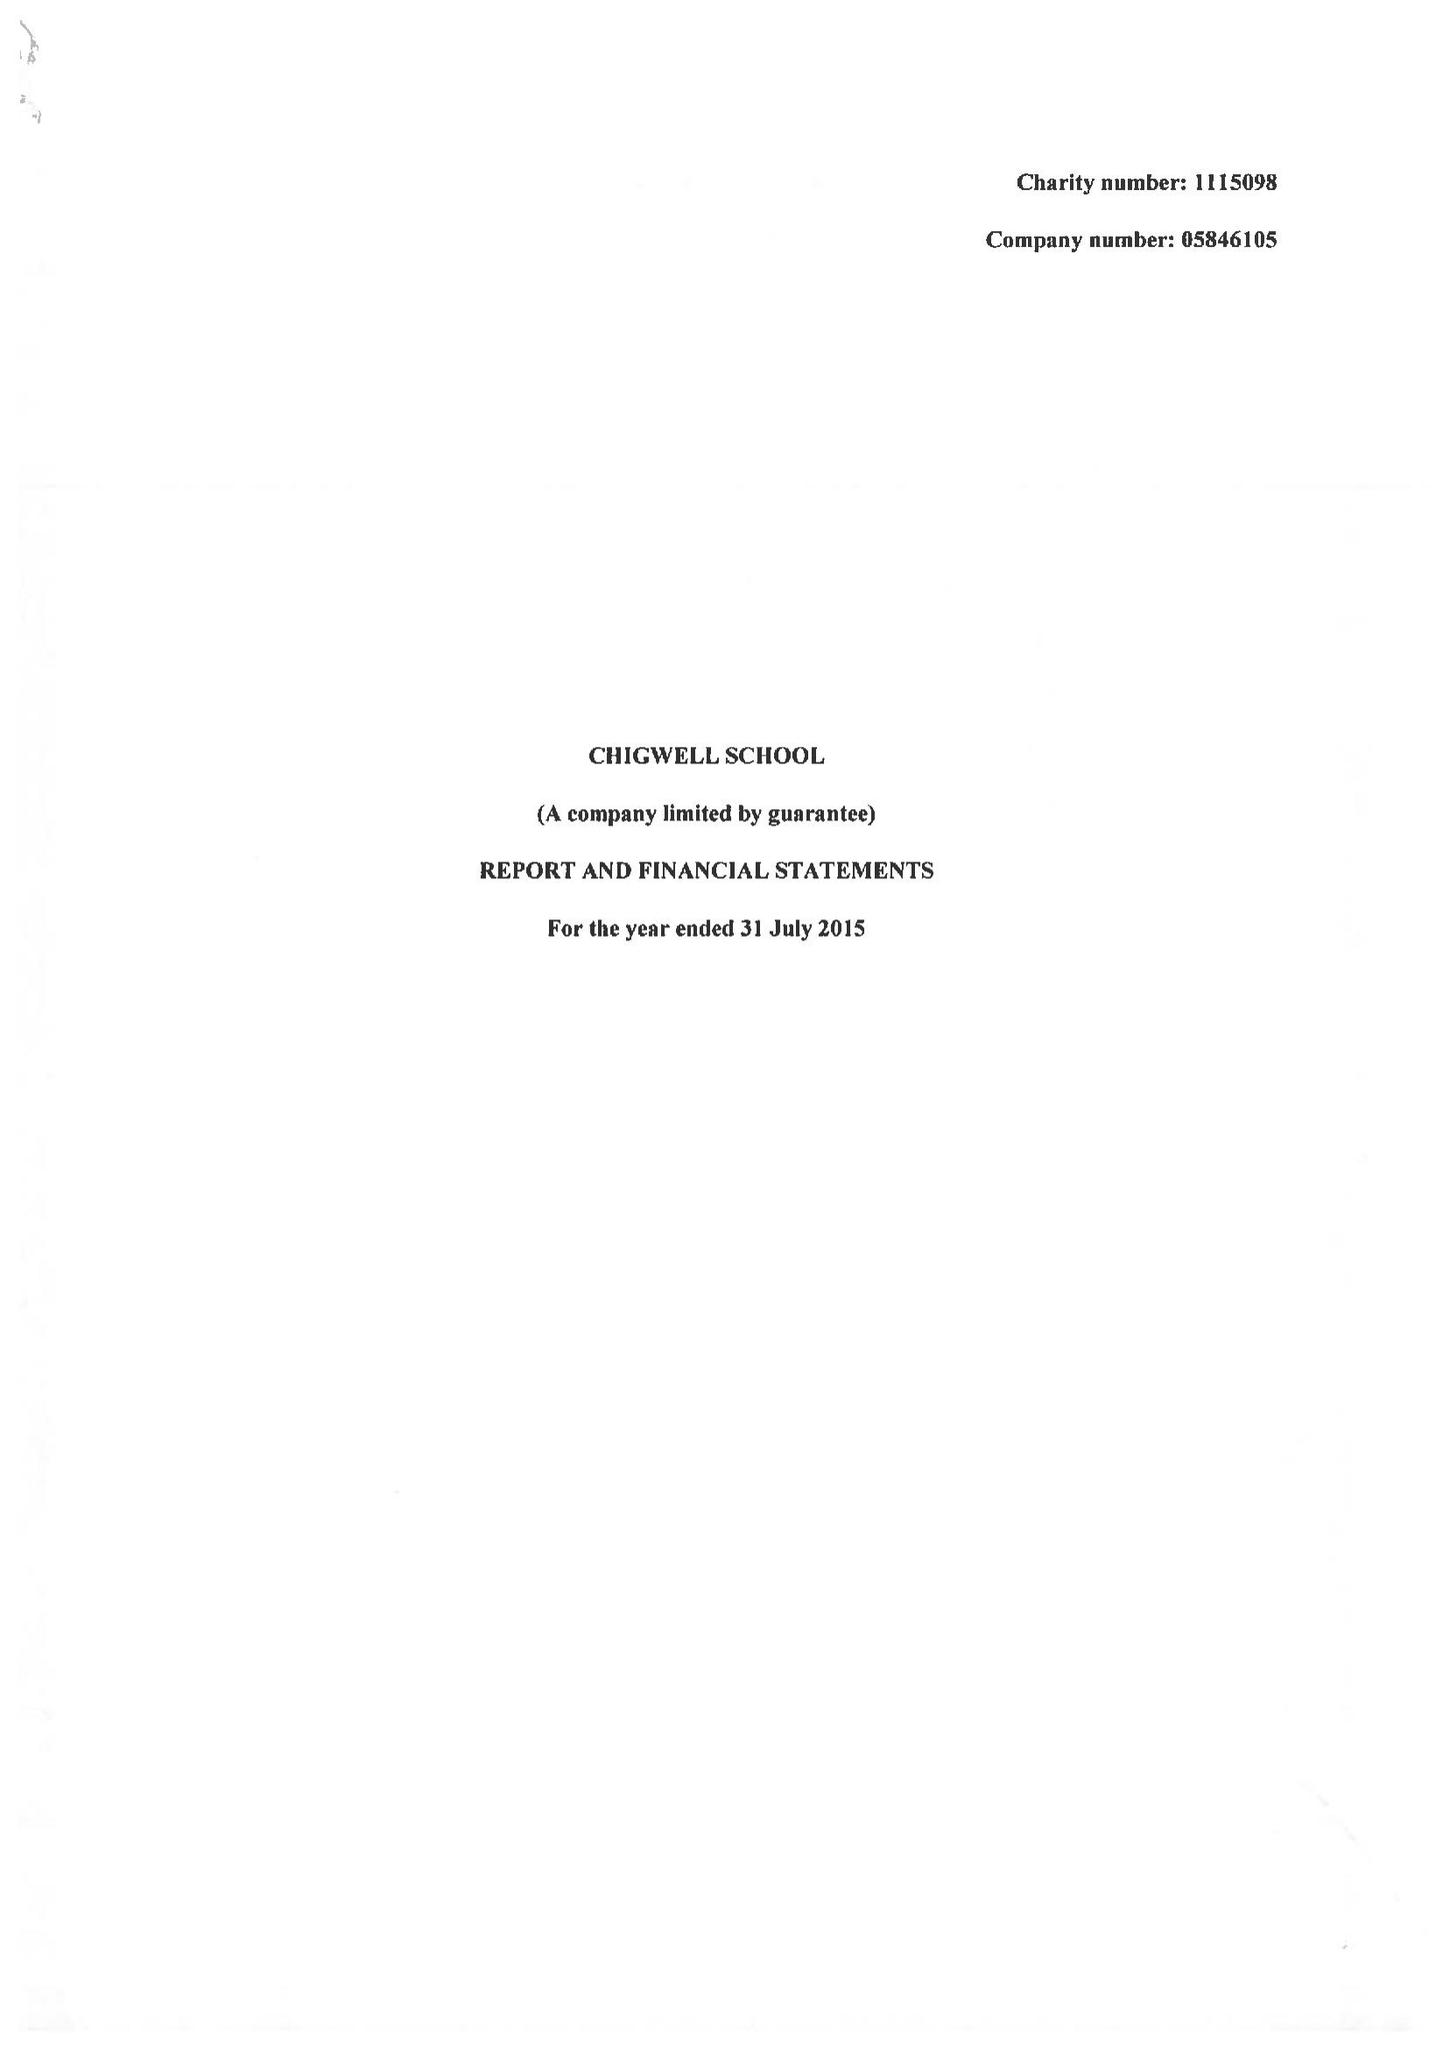What is the value for the income_annually_in_british_pounds?
Answer the question using a single word or phrase. 12404000.00 